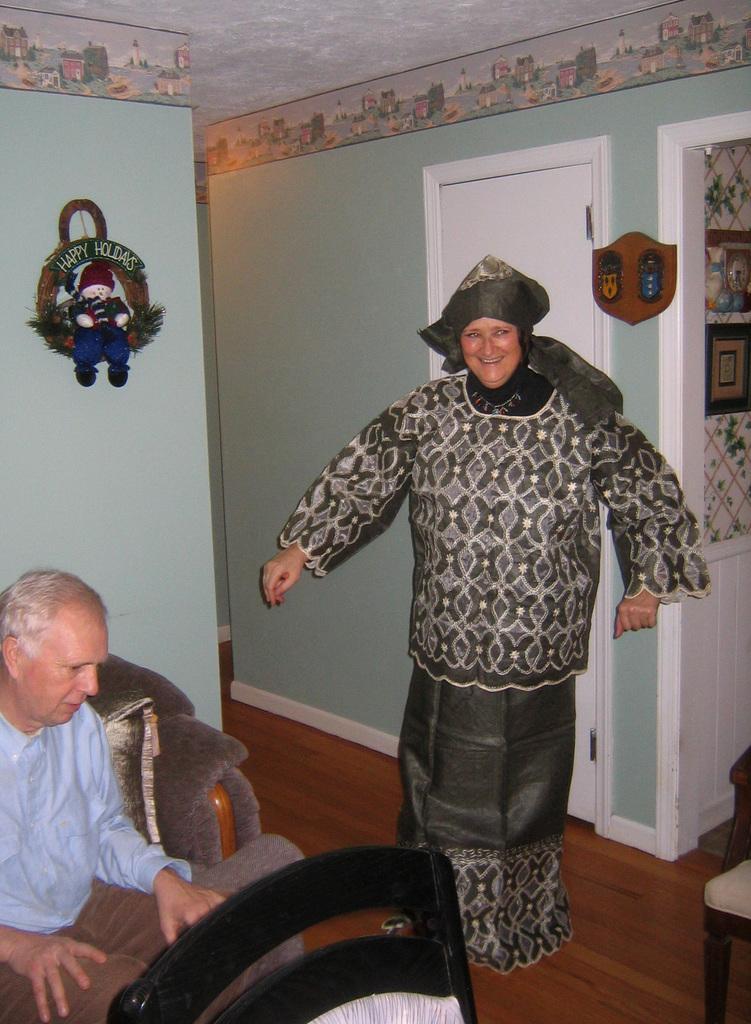In one or two sentences, can you explain what this image depicts? In this picture we can see two people, chairs on the floor, one person is standing, another person is sitting, here we can see a toy, clock, door, wall and some objects and in the background we can see a roof. 